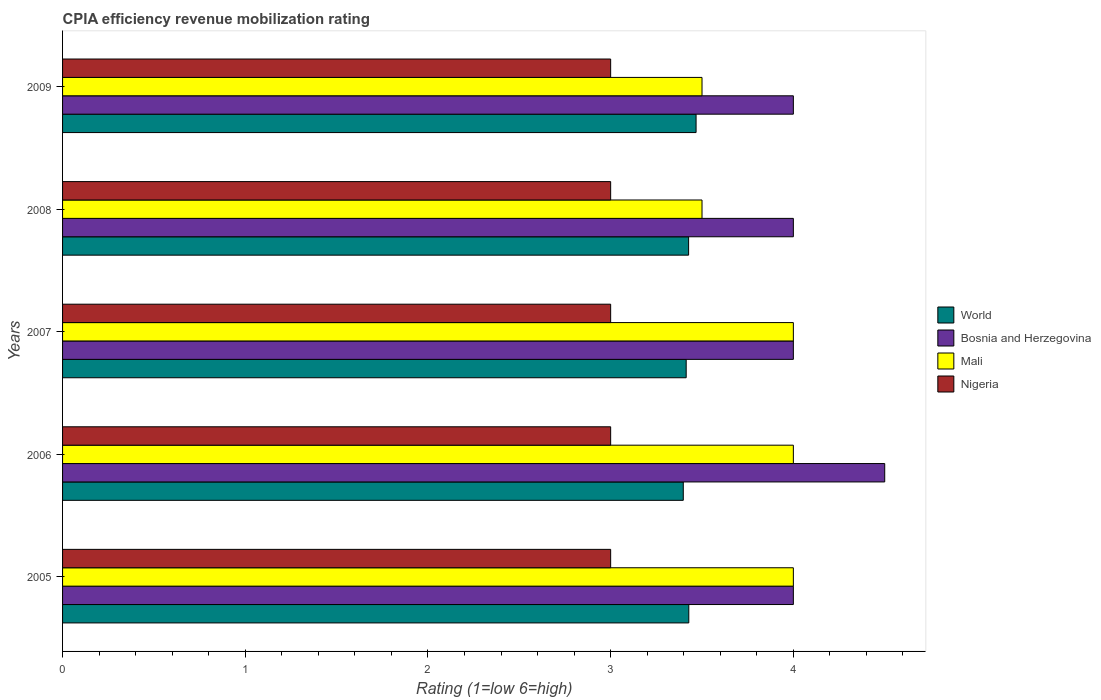How many bars are there on the 5th tick from the top?
Offer a terse response. 4. How many bars are there on the 5th tick from the bottom?
Ensure brevity in your answer.  4. What is the CPIA rating in Mali in 2007?
Your answer should be compact. 4. Across all years, what is the minimum CPIA rating in Nigeria?
Provide a succinct answer. 3. In which year was the CPIA rating in Bosnia and Herzegovina maximum?
Ensure brevity in your answer.  2006. What is the difference between the CPIA rating in World in 2005 and that in 2008?
Make the answer very short. 0. What is the difference between the CPIA rating in Mali in 2008 and the CPIA rating in Bosnia and Herzegovina in 2007?
Make the answer very short. -0.5. What is the average CPIA rating in World per year?
Keep it short and to the point. 3.43. In the year 2008, what is the difference between the CPIA rating in Mali and CPIA rating in World?
Your answer should be very brief. 0.07. What is the ratio of the CPIA rating in World in 2005 to that in 2007?
Offer a very short reply. 1. What is the difference between the highest and the lowest CPIA rating in World?
Provide a short and direct response. 0.07. Is the sum of the CPIA rating in World in 2006 and 2007 greater than the maximum CPIA rating in Nigeria across all years?
Provide a succinct answer. Yes. Is it the case that in every year, the sum of the CPIA rating in Bosnia and Herzegovina and CPIA rating in Mali is greater than the sum of CPIA rating in World and CPIA rating in Nigeria?
Your answer should be compact. Yes. What does the 2nd bar from the top in 2005 represents?
Make the answer very short. Mali. Are all the bars in the graph horizontal?
Provide a short and direct response. Yes. Does the graph contain any zero values?
Offer a terse response. No. Does the graph contain grids?
Provide a short and direct response. No. Where does the legend appear in the graph?
Ensure brevity in your answer.  Center right. What is the title of the graph?
Offer a very short reply. CPIA efficiency revenue mobilization rating. Does "Latin America(all income levels)" appear as one of the legend labels in the graph?
Give a very brief answer. No. What is the label or title of the X-axis?
Your answer should be compact. Rating (1=low 6=high). What is the label or title of the Y-axis?
Offer a very short reply. Years. What is the Rating (1=low 6=high) in World in 2005?
Make the answer very short. 3.43. What is the Rating (1=low 6=high) of World in 2006?
Ensure brevity in your answer.  3.4. What is the Rating (1=low 6=high) in Bosnia and Herzegovina in 2006?
Provide a succinct answer. 4.5. What is the Rating (1=low 6=high) of Mali in 2006?
Provide a short and direct response. 4. What is the Rating (1=low 6=high) of World in 2007?
Keep it short and to the point. 3.41. What is the Rating (1=low 6=high) in Bosnia and Herzegovina in 2007?
Offer a terse response. 4. What is the Rating (1=low 6=high) in Mali in 2007?
Provide a short and direct response. 4. What is the Rating (1=low 6=high) of Nigeria in 2007?
Your response must be concise. 3. What is the Rating (1=low 6=high) of World in 2008?
Your response must be concise. 3.43. What is the Rating (1=low 6=high) in Bosnia and Herzegovina in 2008?
Offer a very short reply. 4. What is the Rating (1=low 6=high) in Mali in 2008?
Offer a very short reply. 3.5. What is the Rating (1=low 6=high) in Nigeria in 2008?
Make the answer very short. 3. What is the Rating (1=low 6=high) of World in 2009?
Provide a short and direct response. 3.47. What is the Rating (1=low 6=high) in Bosnia and Herzegovina in 2009?
Give a very brief answer. 4. What is the Rating (1=low 6=high) of Mali in 2009?
Your answer should be compact. 3.5. Across all years, what is the maximum Rating (1=low 6=high) of World?
Make the answer very short. 3.47. Across all years, what is the minimum Rating (1=low 6=high) in World?
Your answer should be very brief. 3.4. Across all years, what is the minimum Rating (1=low 6=high) of Bosnia and Herzegovina?
Your response must be concise. 4. Across all years, what is the minimum Rating (1=low 6=high) in Mali?
Offer a terse response. 3.5. Across all years, what is the minimum Rating (1=low 6=high) of Nigeria?
Provide a succinct answer. 3. What is the total Rating (1=low 6=high) of World in the graph?
Offer a terse response. 17.13. What is the difference between the Rating (1=low 6=high) of World in 2005 and that in 2006?
Provide a short and direct response. 0.03. What is the difference between the Rating (1=low 6=high) in Mali in 2005 and that in 2006?
Provide a short and direct response. 0. What is the difference between the Rating (1=low 6=high) of World in 2005 and that in 2007?
Keep it short and to the point. 0.01. What is the difference between the Rating (1=low 6=high) of Nigeria in 2005 and that in 2007?
Offer a very short reply. 0. What is the difference between the Rating (1=low 6=high) of Bosnia and Herzegovina in 2005 and that in 2008?
Offer a very short reply. 0. What is the difference between the Rating (1=low 6=high) in World in 2005 and that in 2009?
Offer a very short reply. -0.04. What is the difference between the Rating (1=low 6=high) in World in 2006 and that in 2007?
Offer a very short reply. -0.02. What is the difference between the Rating (1=low 6=high) of Nigeria in 2006 and that in 2007?
Offer a very short reply. 0. What is the difference between the Rating (1=low 6=high) in World in 2006 and that in 2008?
Your response must be concise. -0.03. What is the difference between the Rating (1=low 6=high) in Bosnia and Herzegovina in 2006 and that in 2008?
Your answer should be compact. 0.5. What is the difference between the Rating (1=low 6=high) of World in 2006 and that in 2009?
Offer a terse response. -0.07. What is the difference between the Rating (1=low 6=high) in Mali in 2006 and that in 2009?
Make the answer very short. 0.5. What is the difference between the Rating (1=low 6=high) in Nigeria in 2006 and that in 2009?
Your answer should be very brief. 0. What is the difference between the Rating (1=low 6=high) of World in 2007 and that in 2008?
Keep it short and to the point. -0.01. What is the difference between the Rating (1=low 6=high) in Bosnia and Herzegovina in 2007 and that in 2008?
Offer a terse response. 0. What is the difference between the Rating (1=low 6=high) in Mali in 2007 and that in 2008?
Keep it short and to the point. 0.5. What is the difference between the Rating (1=low 6=high) in Nigeria in 2007 and that in 2008?
Offer a very short reply. 0. What is the difference between the Rating (1=low 6=high) of World in 2007 and that in 2009?
Offer a very short reply. -0.05. What is the difference between the Rating (1=low 6=high) of Bosnia and Herzegovina in 2007 and that in 2009?
Your answer should be very brief. 0. What is the difference between the Rating (1=low 6=high) of Mali in 2007 and that in 2009?
Make the answer very short. 0.5. What is the difference between the Rating (1=low 6=high) in World in 2008 and that in 2009?
Make the answer very short. -0.04. What is the difference between the Rating (1=low 6=high) in Mali in 2008 and that in 2009?
Ensure brevity in your answer.  0. What is the difference between the Rating (1=low 6=high) of Nigeria in 2008 and that in 2009?
Provide a short and direct response. 0. What is the difference between the Rating (1=low 6=high) in World in 2005 and the Rating (1=low 6=high) in Bosnia and Herzegovina in 2006?
Your answer should be compact. -1.07. What is the difference between the Rating (1=low 6=high) in World in 2005 and the Rating (1=low 6=high) in Mali in 2006?
Keep it short and to the point. -0.57. What is the difference between the Rating (1=low 6=high) in World in 2005 and the Rating (1=low 6=high) in Nigeria in 2006?
Your answer should be very brief. 0.43. What is the difference between the Rating (1=low 6=high) of Bosnia and Herzegovina in 2005 and the Rating (1=low 6=high) of Mali in 2006?
Ensure brevity in your answer.  0. What is the difference between the Rating (1=low 6=high) of Bosnia and Herzegovina in 2005 and the Rating (1=low 6=high) of Nigeria in 2006?
Give a very brief answer. 1. What is the difference between the Rating (1=low 6=high) in Mali in 2005 and the Rating (1=low 6=high) in Nigeria in 2006?
Offer a terse response. 1. What is the difference between the Rating (1=low 6=high) in World in 2005 and the Rating (1=low 6=high) in Bosnia and Herzegovina in 2007?
Your answer should be compact. -0.57. What is the difference between the Rating (1=low 6=high) in World in 2005 and the Rating (1=low 6=high) in Mali in 2007?
Make the answer very short. -0.57. What is the difference between the Rating (1=low 6=high) of World in 2005 and the Rating (1=low 6=high) of Nigeria in 2007?
Your answer should be very brief. 0.43. What is the difference between the Rating (1=low 6=high) of Bosnia and Herzegovina in 2005 and the Rating (1=low 6=high) of Mali in 2007?
Your response must be concise. 0. What is the difference between the Rating (1=low 6=high) of Bosnia and Herzegovina in 2005 and the Rating (1=low 6=high) of Nigeria in 2007?
Offer a terse response. 1. What is the difference between the Rating (1=low 6=high) of Mali in 2005 and the Rating (1=low 6=high) of Nigeria in 2007?
Provide a short and direct response. 1. What is the difference between the Rating (1=low 6=high) of World in 2005 and the Rating (1=low 6=high) of Bosnia and Herzegovina in 2008?
Your answer should be very brief. -0.57. What is the difference between the Rating (1=low 6=high) of World in 2005 and the Rating (1=low 6=high) of Mali in 2008?
Provide a succinct answer. -0.07. What is the difference between the Rating (1=low 6=high) in World in 2005 and the Rating (1=low 6=high) in Nigeria in 2008?
Your answer should be compact. 0.43. What is the difference between the Rating (1=low 6=high) in Bosnia and Herzegovina in 2005 and the Rating (1=low 6=high) in Mali in 2008?
Make the answer very short. 0.5. What is the difference between the Rating (1=low 6=high) in Bosnia and Herzegovina in 2005 and the Rating (1=low 6=high) in Nigeria in 2008?
Make the answer very short. 1. What is the difference between the Rating (1=low 6=high) of World in 2005 and the Rating (1=low 6=high) of Bosnia and Herzegovina in 2009?
Provide a succinct answer. -0.57. What is the difference between the Rating (1=low 6=high) of World in 2005 and the Rating (1=low 6=high) of Mali in 2009?
Your answer should be very brief. -0.07. What is the difference between the Rating (1=low 6=high) in World in 2005 and the Rating (1=low 6=high) in Nigeria in 2009?
Your response must be concise. 0.43. What is the difference between the Rating (1=low 6=high) of World in 2006 and the Rating (1=low 6=high) of Bosnia and Herzegovina in 2007?
Your response must be concise. -0.6. What is the difference between the Rating (1=low 6=high) in World in 2006 and the Rating (1=low 6=high) in Mali in 2007?
Offer a very short reply. -0.6. What is the difference between the Rating (1=low 6=high) of World in 2006 and the Rating (1=low 6=high) of Nigeria in 2007?
Offer a very short reply. 0.4. What is the difference between the Rating (1=low 6=high) in Bosnia and Herzegovina in 2006 and the Rating (1=low 6=high) in Mali in 2007?
Make the answer very short. 0.5. What is the difference between the Rating (1=low 6=high) of World in 2006 and the Rating (1=low 6=high) of Bosnia and Herzegovina in 2008?
Keep it short and to the point. -0.6. What is the difference between the Rating (1=low 6=high) of World in 2006 and the Rating (1=low 6=high) of Mali in 2008?
Your answer should be compact. -0.1. What is the difference between the Rating (1=low 6=high) in World in 2006 and the Rating (1=low 6=high) in Nigeria in 2008?
Give a very brief answer. 0.4. What is the difference between the Rating (1=low 6=high) of Bosnia and Herzegovina in 2006 and the Rating (1=low 6=high) of Nigeria in 2008?
Make the answer very short. 1.5. What is the difference between the Rating (1=low 6=high) of World in 2006 and the Rating (1=low 6=high) of Bosnia and Herzegovina in 2009?
Offer a terse response. -0.6. What is the difference between the Rating (1=low 6=high) in World in 2006 and the Rating (1=low 6=high) in Mali in 2009?
Give a very brief answer. -0.1. What is the difference between the Rating (1=low 6=high) of World in 2006 and the Rating (1=low 6=high) of Nigeria in 2009?
Your answer should be very brief. 0.4. What is the difference between the Rating (1=low 6=high) of Bosnia and Herzegovina in 2006 and the Rating (1=low 6=high) of Mali in 2009?
Offer a terse response. 1. What is the difference between the Rating (1=low 6=high) in Bosnia and Herzegovina in 2006 and the Rating (1=low 6=high) in Nigeria in 2009?
Offer a very short reply. 1.5. What is the difference between the Rating (1=low 6=high) of World in 2007 and the Rating (1=low 6=high) of Bosnia and Herzegovina in 2008?
Provide a succinct answer. -0.59. What is the difference between the Rating (1=low 6=high) in World in 2007 and the Rating (1=low 6=high) in Mali in 2008?
Make the answer very short. -0.09. What is the difference between the Rating (1=low 6=high) of World in 2007 and the Rating (1=low 6=high) of Nigeria in 2008?
Keep it short and to the point. 0.41. What is the difference between the Rating (1=low 6=high) of Mali in 2007 and the Rating (1=low 6=high) of Nigeria in 2008?
Your answer should be very brief. 1. What is the difference between the Rating (1=low 6=high) of World in 2007 and the Rating (1=low 6=high) of Bosnia and Herzegovina in 2009?
Keep it short and to the point. -0.59. What is the difference between the Rating (1=low 6=high) in World in 2007 and the Rating (1=low 6=high) in Mali in 2009?
Your answer should be compact. -0.09. What is the difference between the Rating (1=low 6=high) in World in 2007 and the Rating (1=low 6=high) in Nigeria in 2009?
Your answer should be compact. 0.41. What is the difference between the Rating (1=low 6=high) of Bosnia and Herzegovina in 2007 and the Rating (1=low 6=high) of Nigeria in 2009?
Keep it short and to the point. 1. What is the difference between the Rating (1=low 6=high) in Mali in 2007 and the Rating (1=low 6=high) in Nigeria in 2009?
Your answer should be very brief. 1. What is the difference between the Rating (1=low 6=high) in World in 2008 and the Rating (1=low 6=high) in Bosnia and Herzegovina in 2009?
Give a very brief answer. -0.57. What is the difference between the Rating (1=low 6=high) of World in 2008 and the Rating (1=low 6=high) of Mali in 2009?
Ensure brevity in your answer.  -0.07. What is the difference between the Rating (1=low 6=high) in World in 2008 and the Rating (1=low 6=high) in Nigeria in 2009?
Offer a terse response. 0.43. What is the difference between the Rating (1=low 6=high) in Bosnia and Herzegovina in 2008 and the Rating (1=low 6=high) in Nigeria in 2009?
Ensure brevity in your answer.  1. What is the average Rating (1=low 6=high) of World per year?
Your answer should be very brief. 3.43. What is the average Rating (1=low 6=high) in Bosnia and Herzegovina per year?
Provide a short and direct response. 4.1. What is the average Rating (1=low 6=high) of Mali per year?
Your response must be concise. 3.8. In the year 2005, what is the difference between the Rating (1=low 6=high) in World and Rating (1=low 6=high) in Bosnia and Herzegovina?
Provide a short and direct response. -0.57. In the year 2005, what is the difference between the Rating (1=low 6=high) in World and Rating (1=low 6=high) in Mali?
Make the answer very short. -0.57. In the year 2005, what is the difference between the Rating (1=low 6=high) in World and Rating (1=low 6=high) in Nigeria?
Ensure brevity in your answer.  0.43. In the year 2005, what is the difference between the Rating (1=low 6=high) in Bosnia and Herzegovina and Rating (1=low 6=high) in Nigeria?
Offer a very short reply. 1. In the year 2005, what is the difference between the Rating (1=low 6=high) of Mali and Rating (1=low 6=high) of Nigeria?
Provide a succinct answer. 1. In the year 2006, what is the difference between the Rating (1=low 6=high) in World and Rating (1=low 6=high) in Bosnia and Herzegovina?
Provide a succinct answer. -1.1. In the year 2006, what is the difference between the Rating (1=low 6=high) in World and Rating (1=low 6=high) in Mali?
Your answer should be very brief. -0.6. In the year 2006, what is the difference between the Rating (1=low 6=high) of World and Rating (1=low 6=high) of Nigeria?
Keep it short and to the point. 0.4. In the year 2006, what is the difference between the Rating (1=low 6=high) of Bosnia and Herzegovina and Rating (1=low 6=high) of Nigeria?
Keep it short and to the point. 1.5. In the year 2007, what is the difference between the Rating (1=low 6=high) of World and Rating (1=low 6=high) of Bosnia and Herzegovina?
Provide a succinct answer. -0.59. In the year 2007, what is the difference between the Rating (1=low 6=high) in World and Rating (1=low 6=high) in Mali?
Your answer should be compact. -0.59. In the year 2007, what is the difference between the Rating (1=low 6=high) in World and Rating (1=low 6=high) in Nigeria?
Ensure brevity in your answer.  0.41. In the year 2007, what is the difference between the Rating (1=low 6=high) in Bosnia and Herzegovina and Rating (1=low 6=high) in Mali?
Keep it short and to the point. 0. In the year 2008, what is the difference between the Rating (1=low 6=high) of World and Rating (1=low 6=high) of Bosnia and Herzegovina?
Keep it short and to the point. -0.57. In the year 2008, what is the difference between the Rating (1=low 6=high) in World and Rating (1=low 6=high) in Mali?
Your response must be concise. -0.07. In the year 2008, what is the difference between the Rating (1=low 6=high) in World and Rating (1=low 6=high) in Nigeria?
Provide a succinct answer. 0.43. In the year 2008, what is the difference between the Rating (1=low 6=high) of Bosnia and Herzegovina and Rating (1=low 6=high) of Mali?
Provide a succinct answer. 0.5. In the year 2008, what is the difference between the Rating (1=low 6=high) in Mali and Rating (1=low 6=high) in Nigeria?
Provide a short and direct response. 0.5. In the year 2009, what is the difference between the Rating (1=low 6=high) of World and Rating (1=low 6=high) of Bosnia and Herzegovina?
Provide a short and direct response. -0.53. In the year 2009, what is the difference between the Rating (1=low 6=high) in World and Rating (1=low 6=high) in Mali?
Offer a very short reply. -0.03. In the year 2009, what is the difference between the Rating (1=low 6=high) in World and Rating (1=low 6=high) in Nigeria?
Provide a succinct answer. 0.47. In the year 2009, what is the difference between the Rating (1=low 6=high) in Bosnia and Herzegovina and Rating (1=low 6=high) in Mali?
Provide a short and direct response. 0.5. What is the ratio of the Rating (1=low 6=high) in World in 2005 to that in 2006?
Offer a terse response. 1.01. What is the ratio of the Rating (1=low 6=high) of World in 2005 to that in 2007?
Keep it short and to the point. 1. What is the ratio of the Rating (1=low 6=high) in Bosnia and Herzegovina in 2005 to that in 2007?
Offer a very short reply. 1. What is the ratio of the Rating (1=low 6=high) in Nigeria in 2005 to that in 2008?
Give a very brief answer. 1. What is the ratio of the Rating (1=low 6=high) in World in 2005 to that in 2009?
Give a very brief answer. 0.99. What is the ratio of the Rating (1=low 6=high) in Mali in 2005 to that in 2009?
Provide a succinct answer. 1.14. What is the ratio of the Rating (1=low 6=high) of World in 2006 to that in 2007?
Ensure brevity in your answer.  1. What is the ratio of the Rating (1=low 6=high) in Bosnia and Herzegovina in 2006 to that in 2007?
Give a very brief answer. 1.12. What is the ratio of the Rating (1=low 6=high) in Mali in 2006 to that in 2007?
Provide a succinct answer. 1. What is the ratio of the Rating (1=low 6=high) of Nigeria in 2006 to that in 2007?
Your answer should be very brief. 1. What is the ratio of the Rating (1=low 6=high) of Bosnia and Herzegovina in 2006 to that in 2008?
Provide a short and direct response. 1.12. What is the ratio of the Rating (1=low 6=high) in Nigeria in 2006 to that in 2008?
Offer a very short reply. 1. What is the ratio of the Rating (1=low 6=high) in World in 2006 to that in 2009?
Offer a terse response. 0.98. What is the ratio of the Rating (1=low 6=high) of Bosnia and Herzegovina in 2006 to that in 2009?
Provide a short and direct response. 1.12. What is the ratio of the Rating (1=low 6=high) in Mali in 2006 to that in 2009?
Keep it short and to the point. 1.14. What is the ratio of the Rating (1=low 6=high) in Nigeria in 2006 to that in 2009?
Keep it short and to the point. 1. What is the ratio of the Rating (1=low 6=high) of World in 2007 to that in 2008?
Make the answer very short. 1. What is the ratio of the Rating (1=low 6=high) of Bosnia and Herzegovina in 2007 to that in 2008?
Ensure brevity in your answer.  1. What is the ratio of the Rating (1=low 6=high) in World in 2007 to that in 2009?
Give a very brief answer. 0.98. What is the ratio of the Rating (1=low 6=high) of Mali in 2007 to that in 2009?
Give a very brief answer. 1.14. What is the ratio of the Rating (1=low 6=high) in Nigeria in 2007 to that in 2009?
Give a very brief answer. 1. What is the ratio of the Rating (1=low 6=high) in World in 2008 to that in 2009?
Your answer should be compact. 0.99. What is the ratio of the Rating (1=low 6=high) of Nigeria in 2008 to that in 2009?
Your answer should be compact. 1. What is the difference between the highest and the second highest Rating (1=low 6=high) in World?
Give a very brief answer. 0.04. What is the difference between the highest and the second highest Rating (1=low 6=high) in Bosnia and Herzegovina?
Your answer should be compact. 0.5. What is the difference between the highest and the lowest Rating (1=low 6=high) in World?
Keep it short and to the point. 0.07. What is the difference between the highest and the lowest Rating (1=low 6=high) in Bosnia and Herzegovina?
Provide a short and direct response. 0.5. 